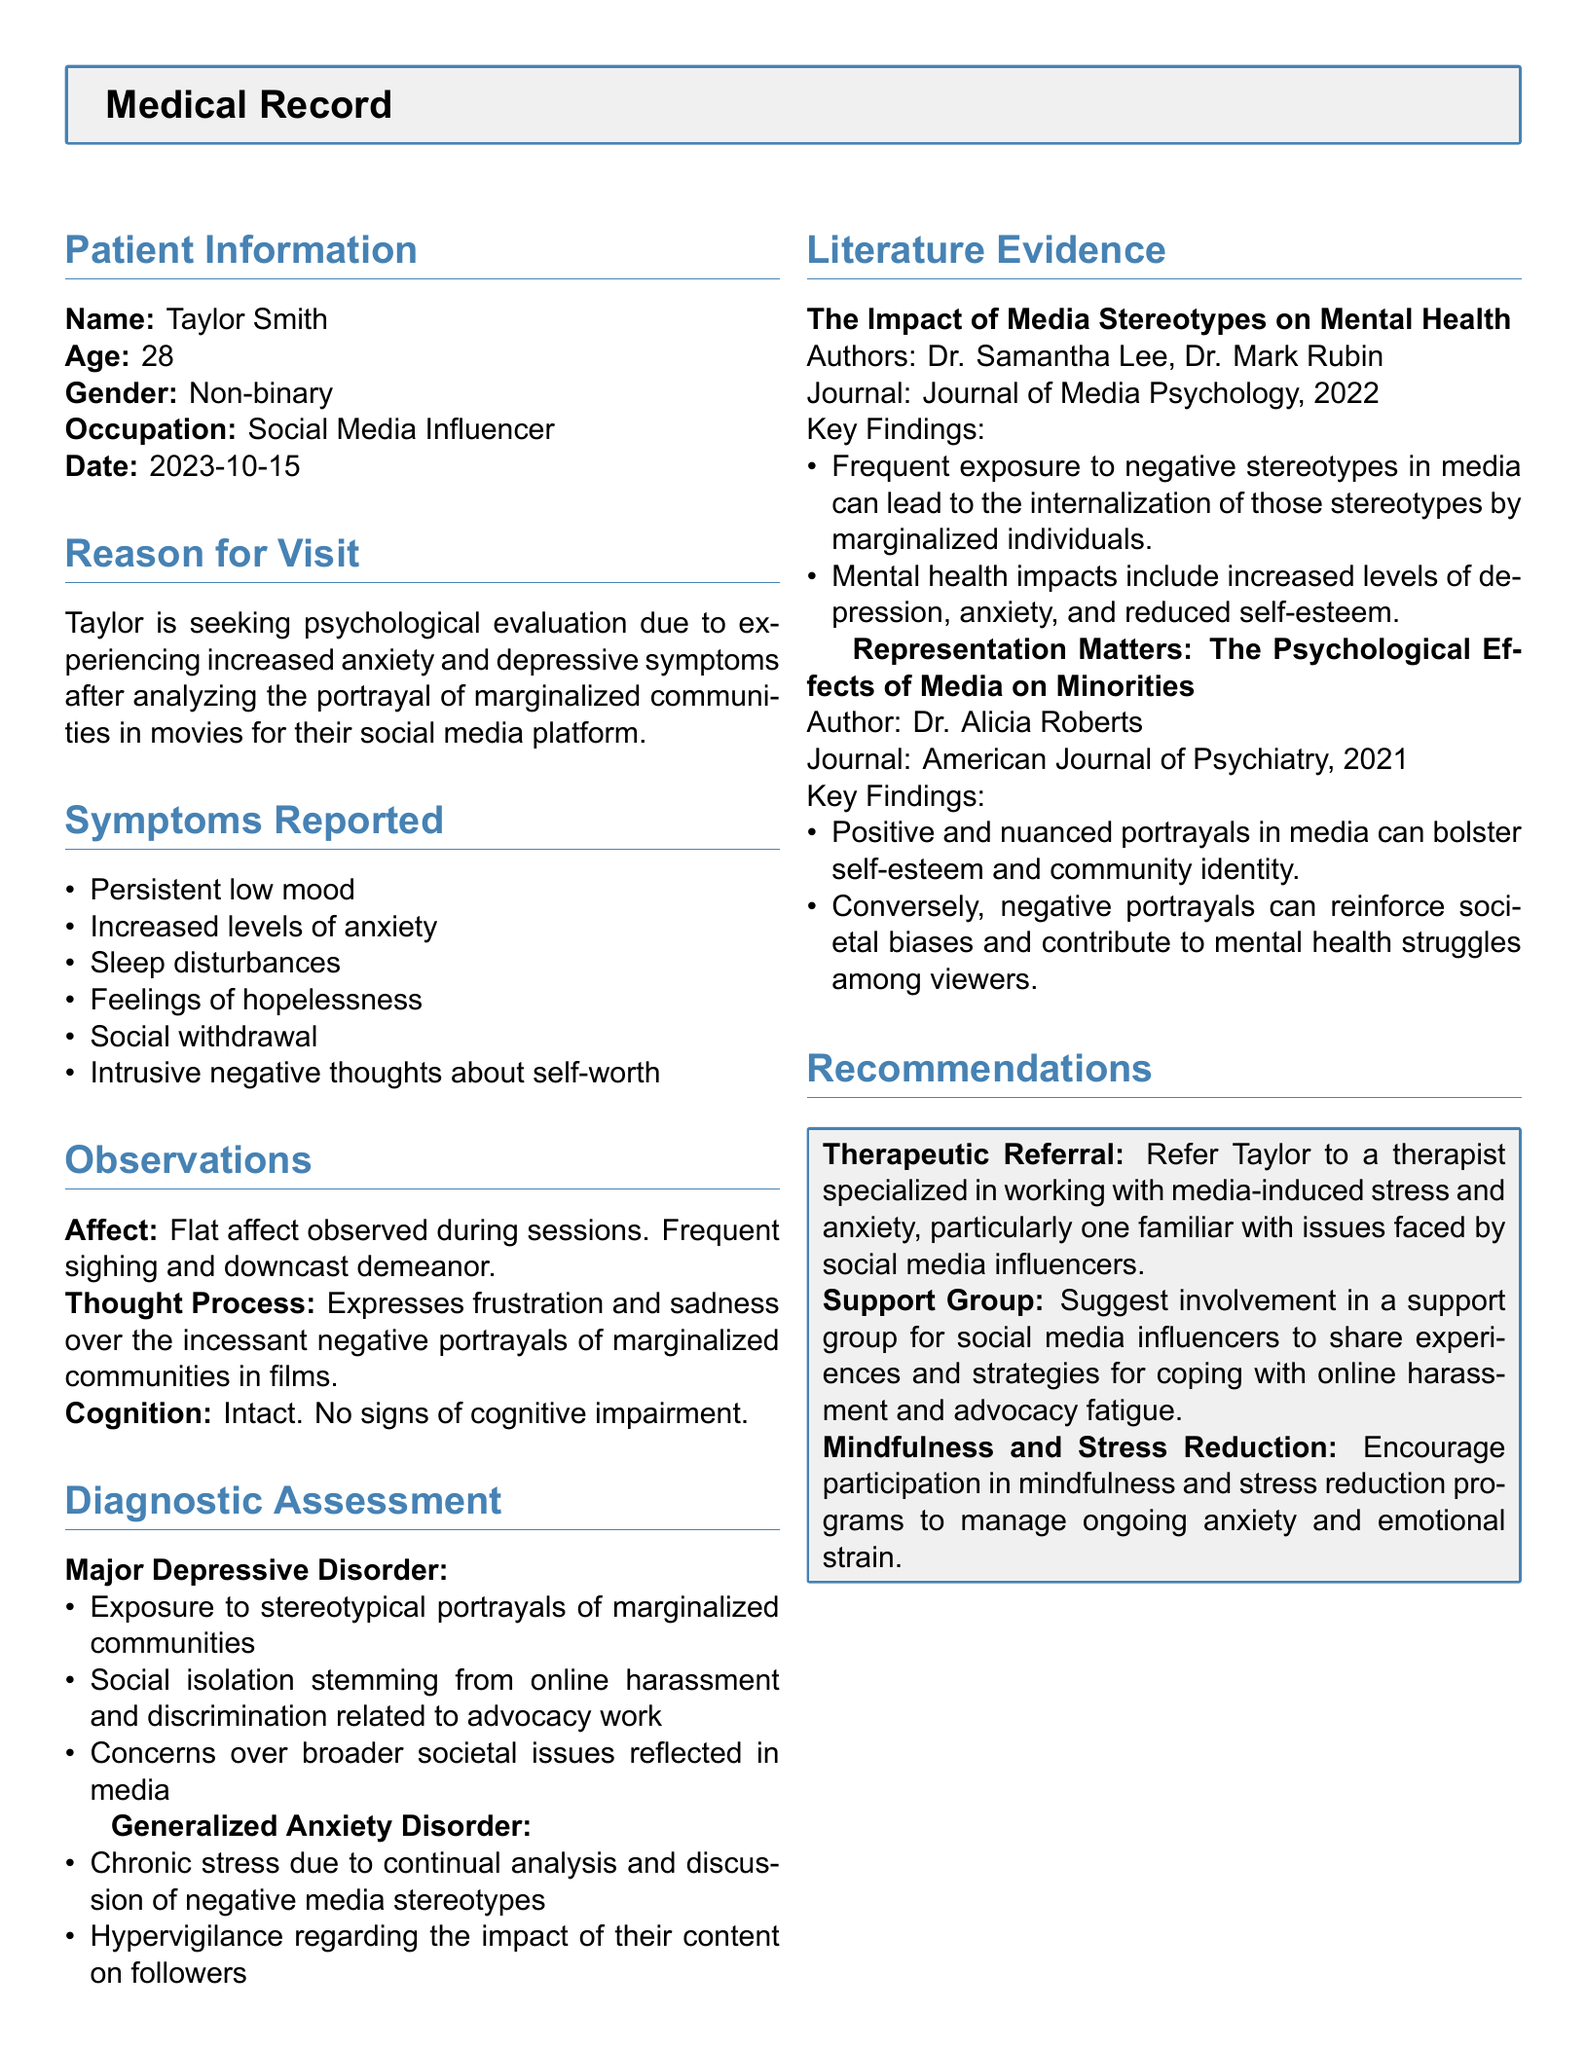what is the patient's name? The patient's name is mentioned in the Patient Information section of the document.
Answer: Taylor Smith what is the date of the evaluation? The date of the evaluation is specified in the Patient Information section.
Answer: 2023-10-15 what are two symptoms reported by the patient? The symptoms reported are listed in the Symptoms Reported section.
Answer: Persistent low mood, Increased levels of anxiety what diagnosis is assessed for the patient? The diagnoses are detailed under the Diagnostic Assessment section of the document.
Answer: Major Depressive Disorder, Generalized Anxiety Disorder who is one of the authors of the literature evidence? The authors of the literature evidence are stated in the Literature Evidence section.
Answer: Dr. Samantha Lee how does the patient's online advocacy work affect their mental health? The document discusses the impact of online harassment and discrimination on the patient's mental state.
Answer: Social isolation stemming from online harassment and discrimination what therapeutic referral is recommended? The recommendations section mentions what type of referral should be made.
Answer: Therapist specialized in media-induced stress what are the emotional symptoms the patient exhibits? Emotional symptoms are observed in the Observations section.
Answer: Flat affect, downcast demeanor how many research articles are referenced in the literature evidence? The number of articles can be counted from the Literature Evidence section of the document.
Answer: Two 